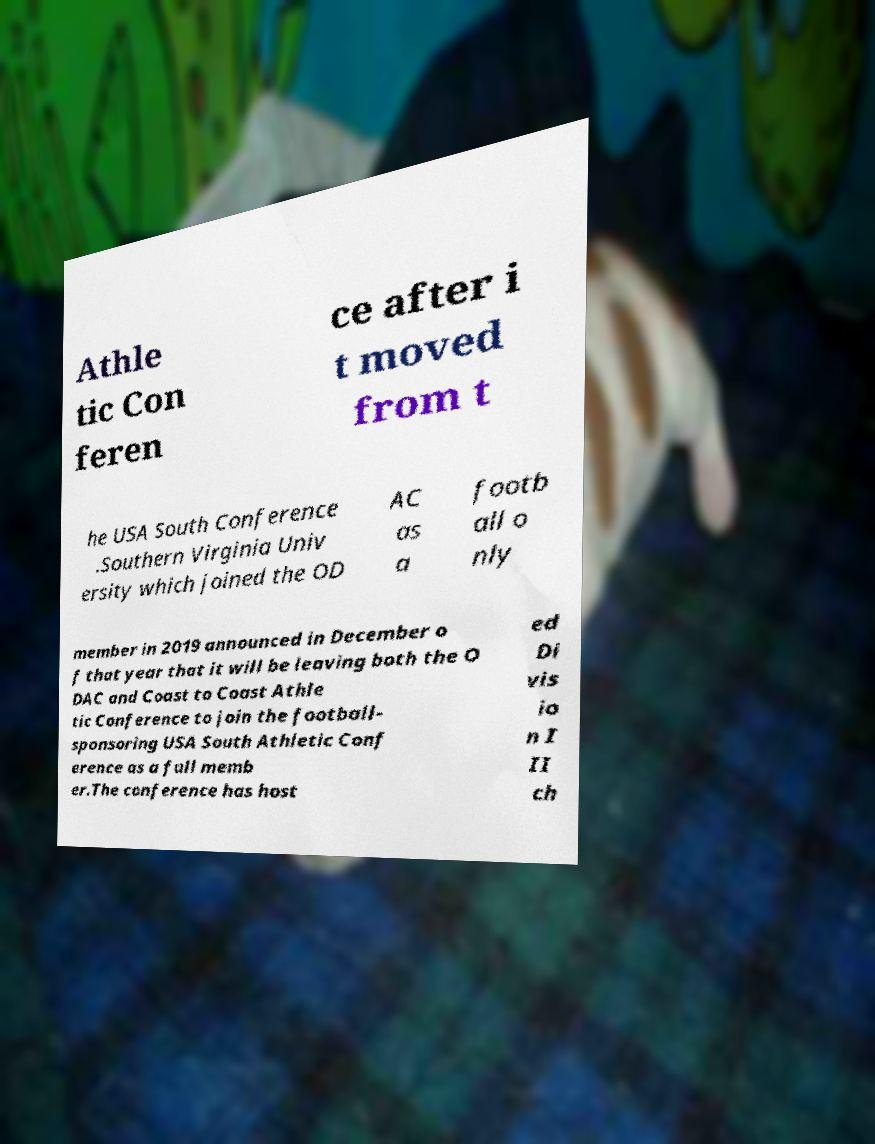Could you assist in decoding the text presented in this image and type it out clearly? Athle tic Con feren ce after i t moved from t he USA South Conference .Southern Virginia Univ ersity which joined the OD AC as a footb all o nly member in 2019 announced in December o f that year that it will be leaving both the O DAC and Coast to Coast Athle tic Conference to join the football- sponsoring USA South Athletic Conf erence as a full memb er.The conference has host ed Di vis io n I II ch 